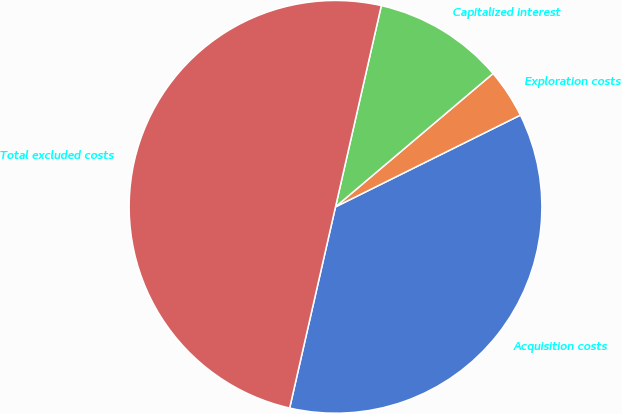Convert chart to OTSL. <chart><loc_0><loc_0><loc_500><loc_500><pie_chart><fcel>Acquisition costs<fcel>Exploration costs<fcel>Capitalized interest<fcel>Total excluded costs<nl><fcel>35.9%<fcel>3.85%<fcel>10.26%<fcel>50.0%<nl></chart> 